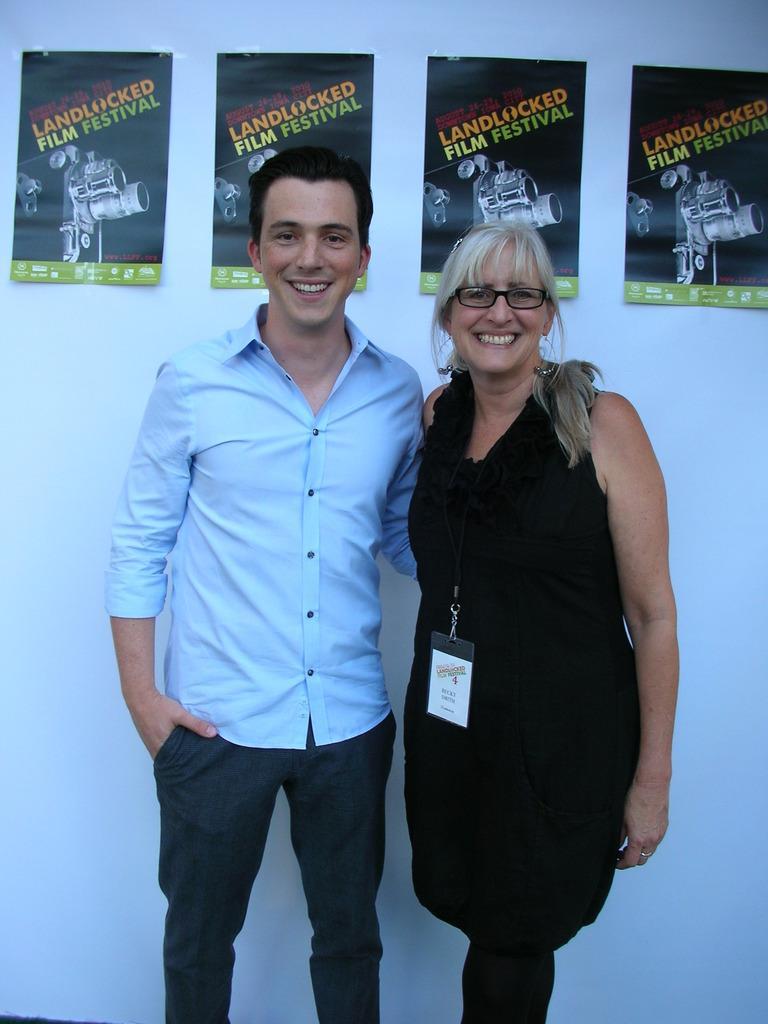In one or two sentences, can you explain what this image depicts? In this picture we can observe a couple. One of them was a man wearing blue color shirt and the other was a woman wearing black color dress and spectacles. Both of them were smiling. In the background there are some papers stuck to the wall. The wall is in white color. 